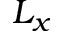<formula> <loc_0><loc_0><loc_500><loc_500>L _ { x }</formula> 